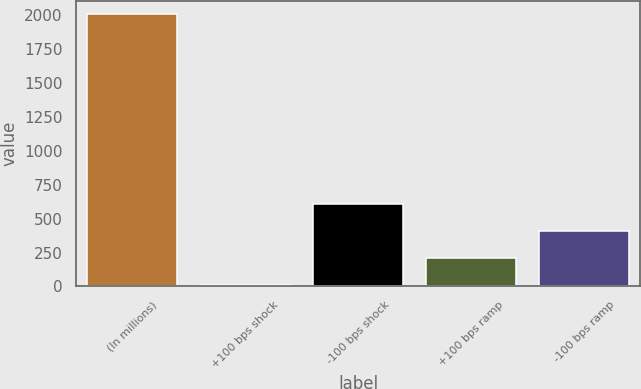Convert chart to OTSL. <chart><loc_0><loc_0><loc_500><loc_500><bar_chart><fcel>(In millions)<fcel>+100 bps shock<fcel>-100 bps shock<fcel>+100 bps ramp<fcel>-100 bps ramp<nl><fcel>2008<fcel>7<fcel>607.3<fcel>207.1<fcel>407.2<nl></chart> 